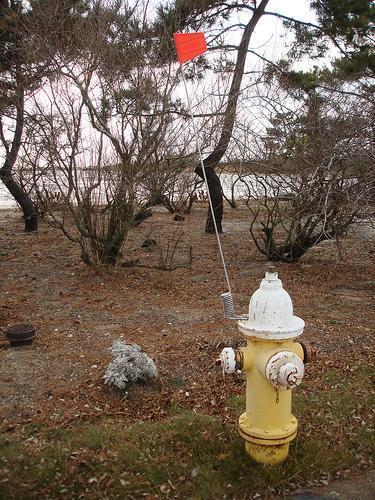How many flags are there?
Give a very brief answer. 1. How many fire hydrants are shown?
Give a very brief answer. 1. 